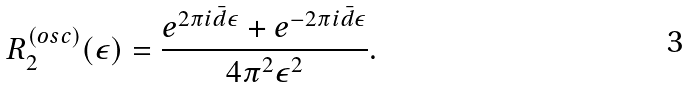Convert formula to latex. <formula><loc_0><loc_0><loc_500><loc_500>R _ { 2 } ^ { ( o s c ) } ( \epsilon ) = \frac { e ^ { 2 \pi i \bar { d } \epsilon } + e ^ { - 2 \pi i \bar { d } \epsilon } } { 4 \pi ^ { 2 } \epsilon ^ { 2 } } .</formula> 